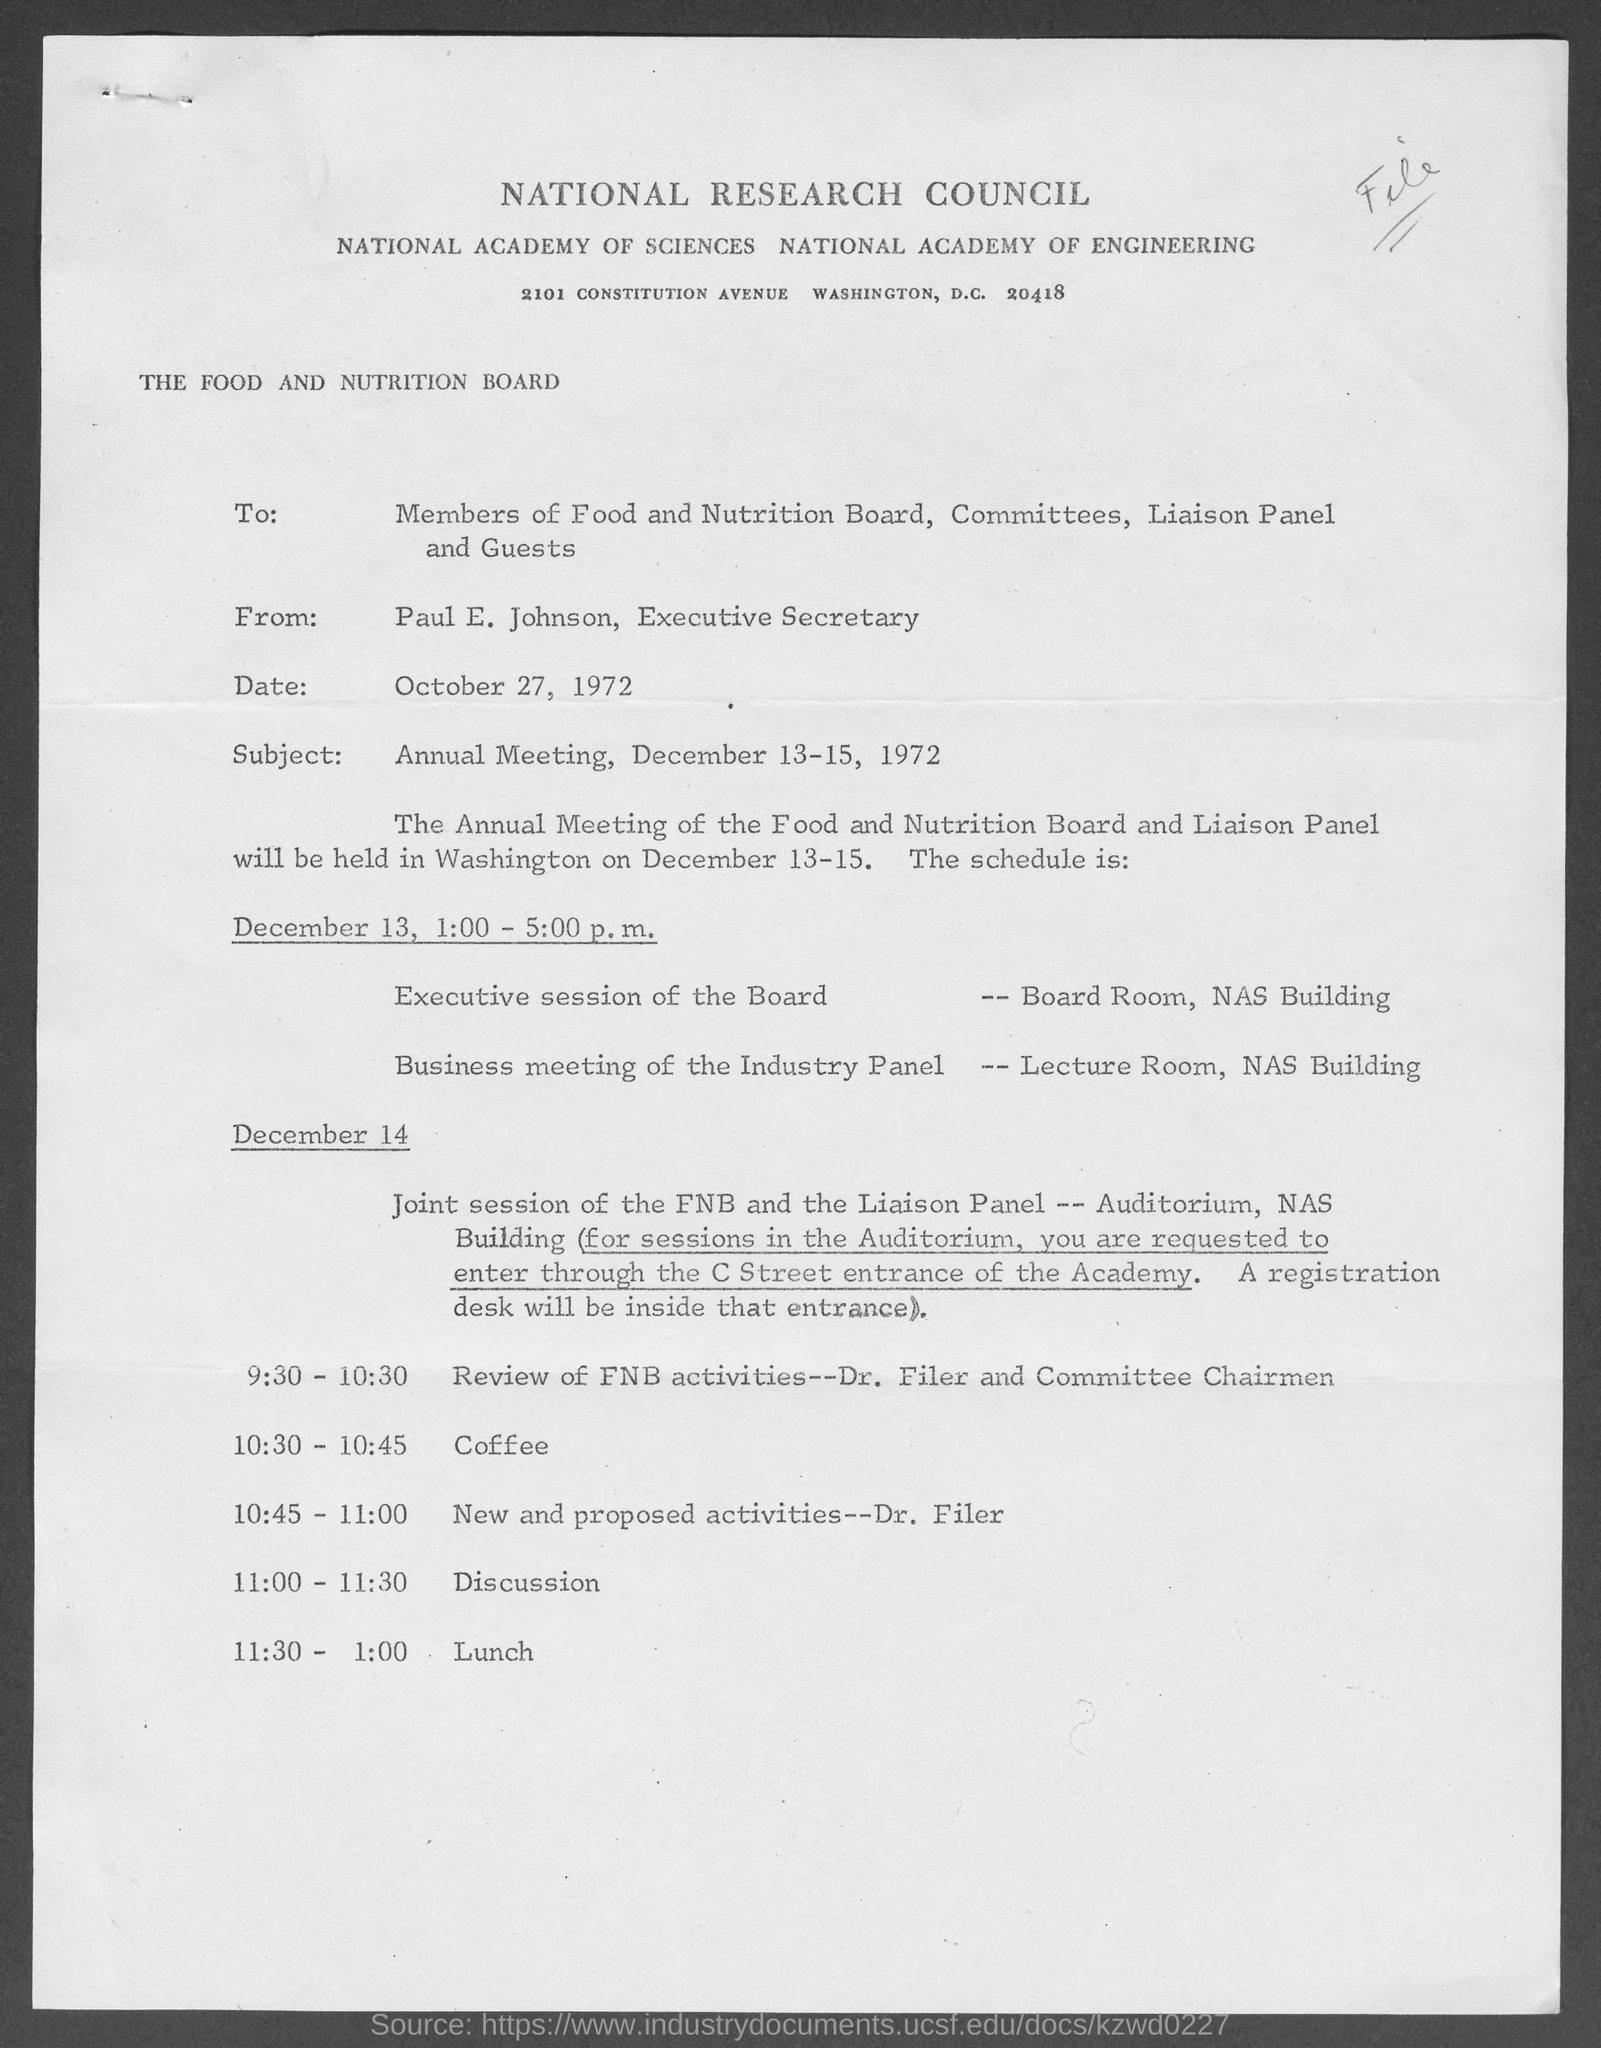Draw attention to some important aspects in this diagram. At 11:00-11:30 on December 14, the discussion is scheduled. The review of FNB activities is scheduled to take place between 9:30 and 10:30. The subject of the letter is the Annual Meeting. The executive secretary of the National Research Council is Paul E. Johnson. 